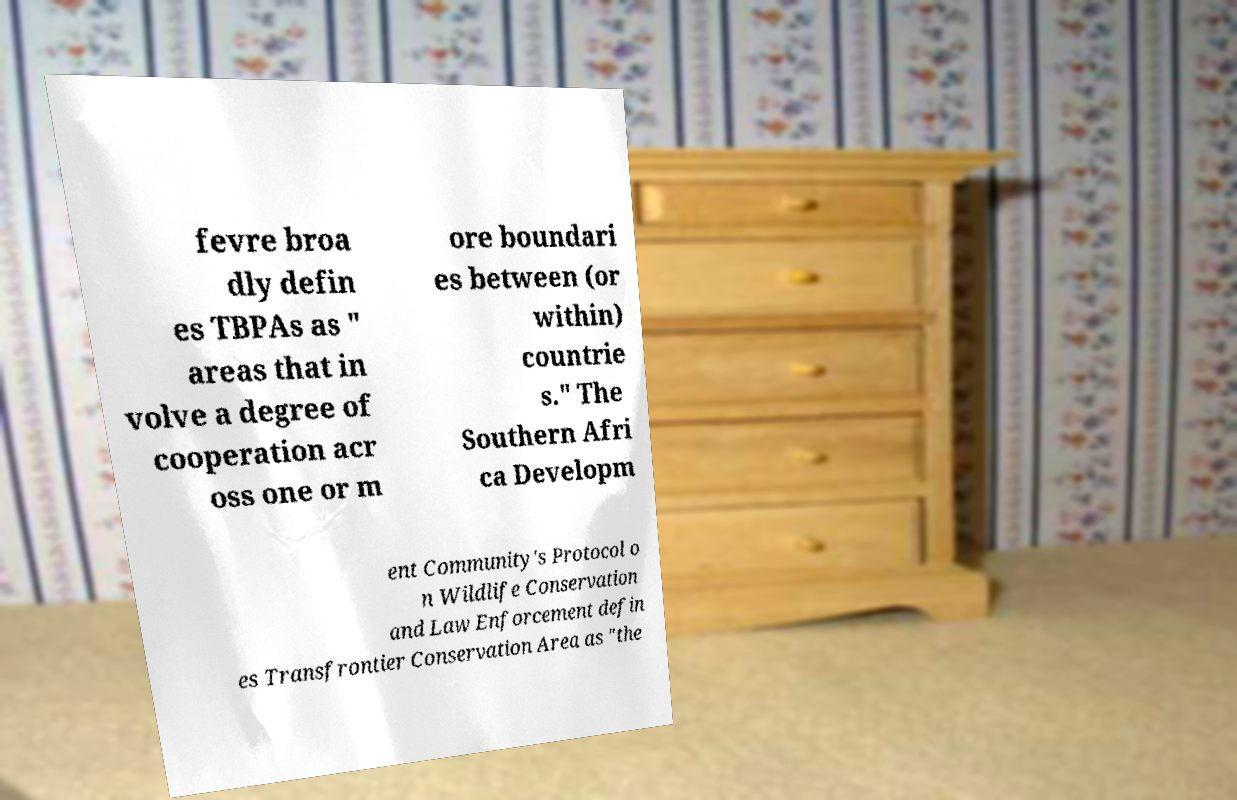For documentation purposes, I need the text within this image transcribed. Could you provide that? fevre broa dly defin es TBPAs as " areas that in volve a degree of cooperation acr oss one or m ore boundari es between (or within) countrie s." The Southern Afri ca Developm ent Community's Protocol o n Wildlife Conservation and Law Enforcement defin es Transfrontier Conservation Area as "the 